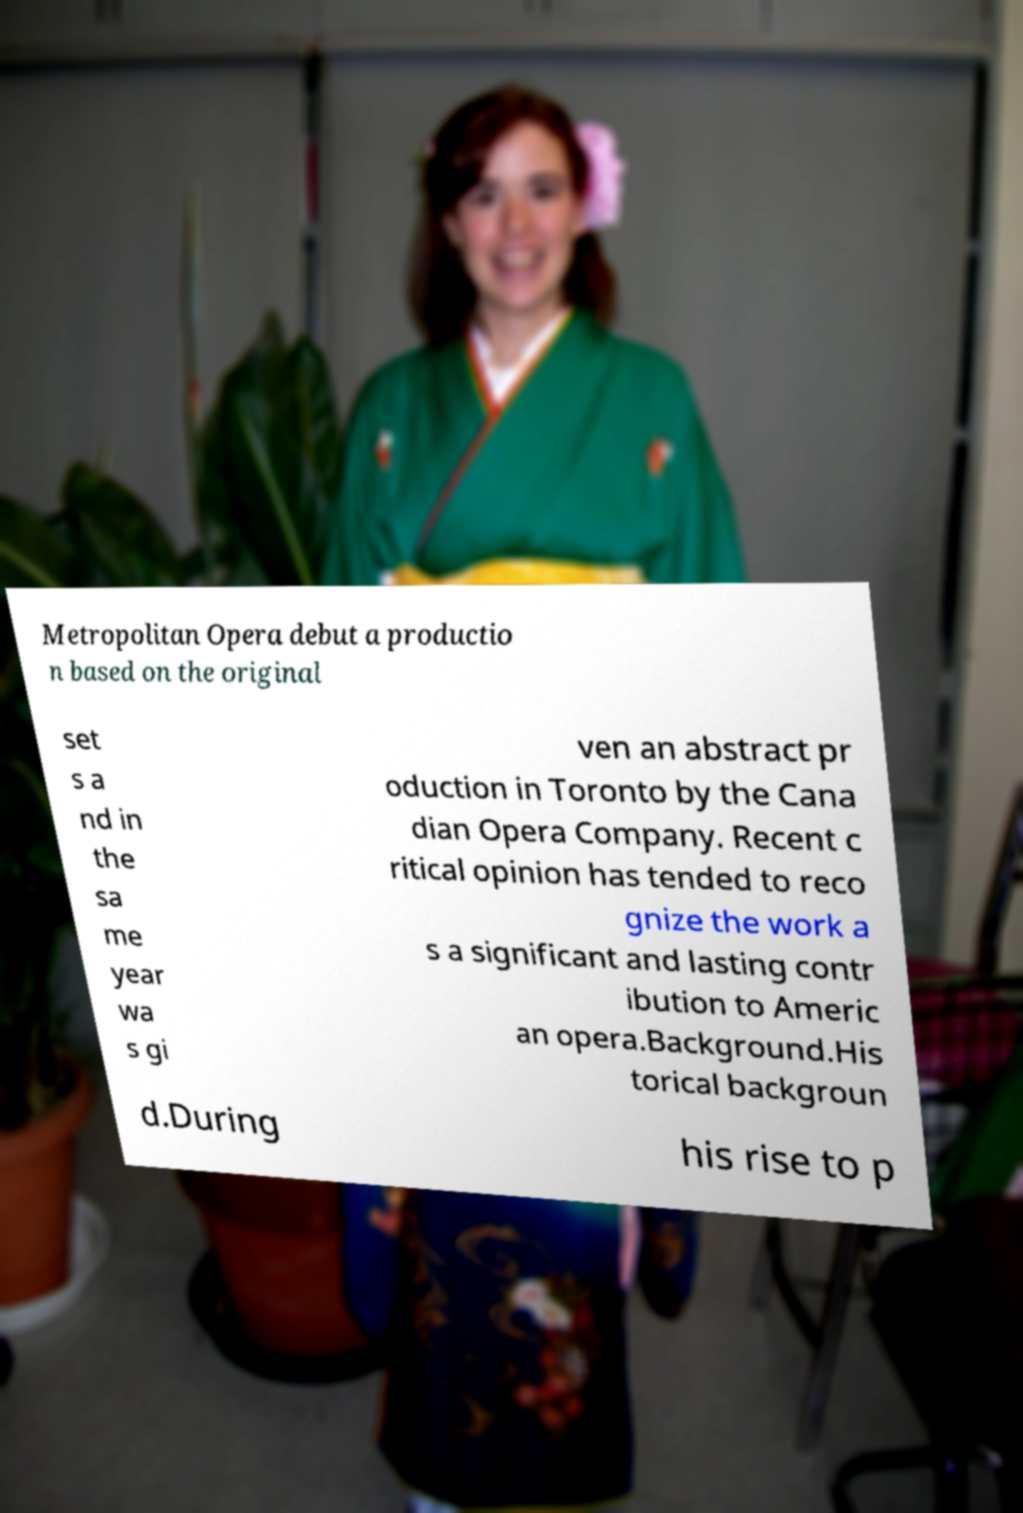Please identify and transcribe the text found in this image. Metropolitan Opera debut a productio n based on the original set s a nd in the sa me year wa s gi ven an abstract pr oduction in Toronto by the Cana dian Opera Company. Recent c ritical opinion has tended to reco gnize the work a s a significant and lasting contr ibution to Americ an opera.Background.His torical backgroun d.During his rise to p 